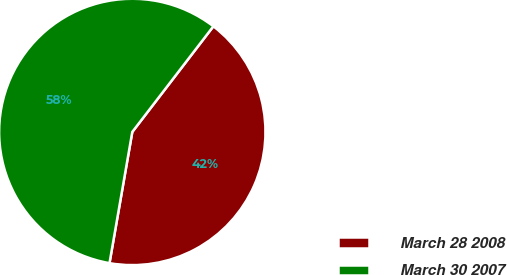Convert chart to OTSL. <chart><loc_0><loc_0><loc_500><loc_500><pie_chart><fcel>March 28 2008<fcel>March 30 2007<nl><fcel>42.32%<fcel>57.68%<nl></chart> 